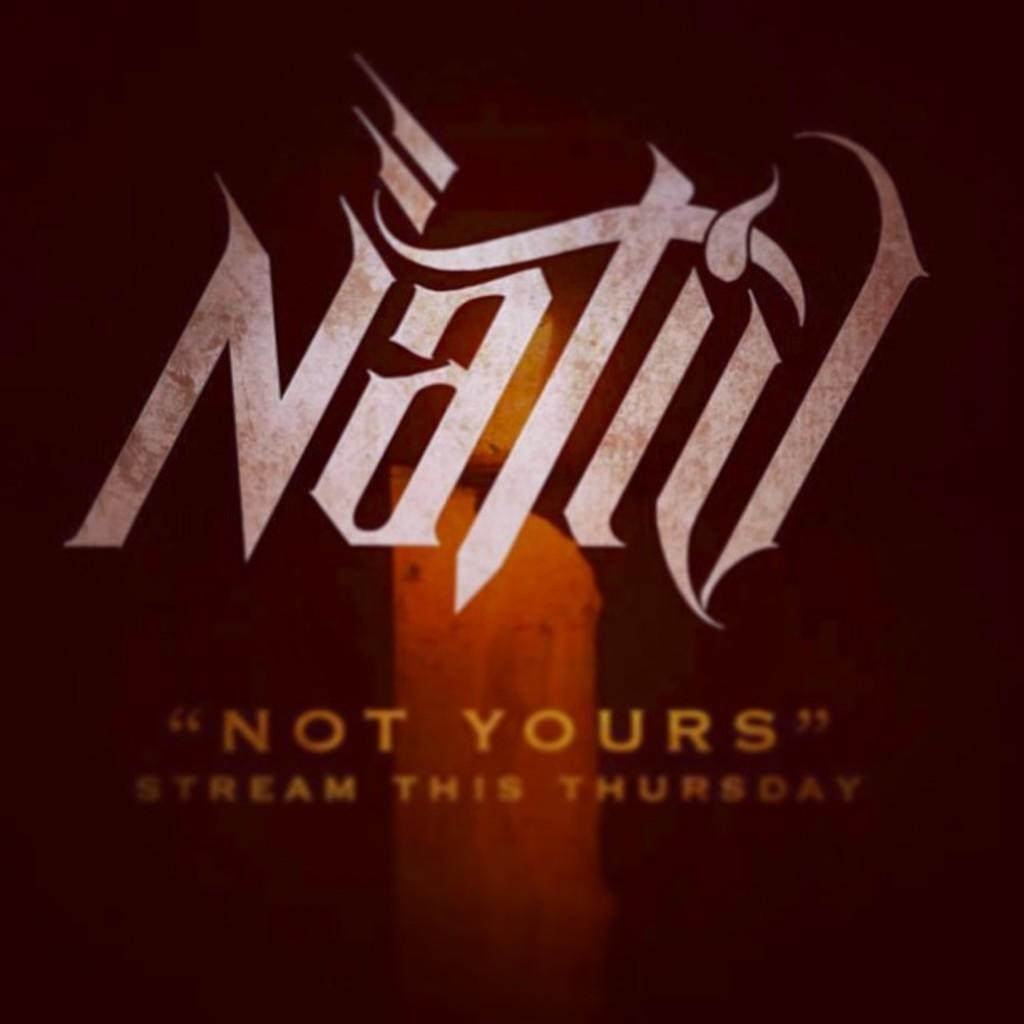<image>
Offer a succinct explanation of the picture presented. Not Yours will be available to stream starting on Thursday, according to this ad. 